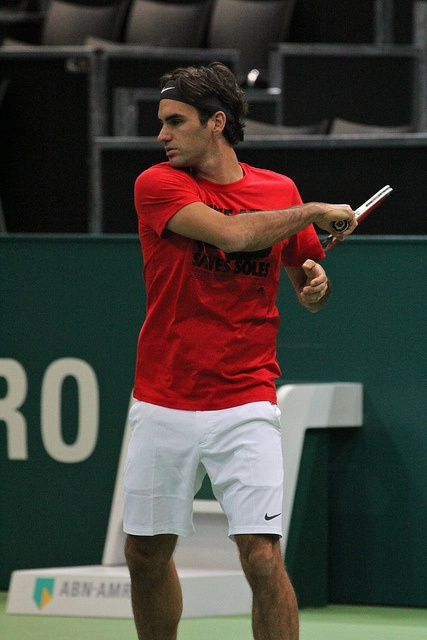Describe the objects in this image and their specific colors. I can see people in black, maroon, and darkgray tones and tennis racket in black, white, maroon, and darkgray tones in this image. 